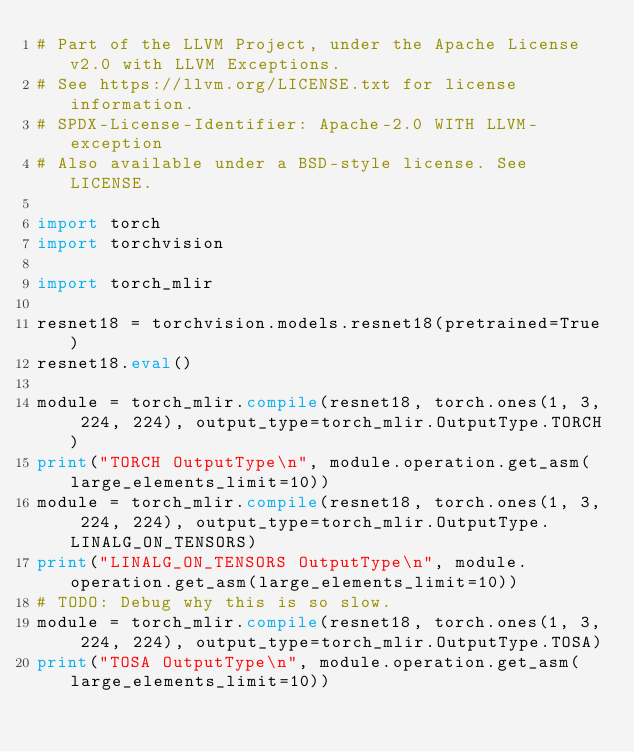Convert code to text. <code><loc_0><loc_0><loc_500><loc_500><_Python_># Part of the LLVM Project, under the Apache License v2.0 with LLVM Exceptions.
# See https://llvm.org/LICENSE.txt for license information.
# SPDX-License-Identifier: Apache-2.0 WITH LLVM-exception
# Also available under a BSD-style license. See LICENSE.

import torch
import torchvision

import torch_mlir

resnet18 = torchvision.models.resnet18(pretrained=True)
resnet18.eval()

module = torch_mlir.compile(resnet18, torch.ones(1, 3, 224, 224), output_type=torch_mlir.OutputType.TORCH)
print("TORCH OutputType\n", module.operation.get_asm(large_elements_limit=10))
module = torch_mlir.compile(resnet18, torch.ones(1, 3, 224, 224), output_type=torch_mlir.OutputType.LINALG_ON_TENSORS)
print("LINALG_ON_TENSORS OutputType\n", module.operation.get_asm(large_elements_limit=10))
# TODO: Debug why this is so slow.
module = torch_mlir.compile(resnet18, torch.ones(1, 3, 224, 224), output_type=torch_mlir.OutputType.TOSA)
print("TOSA OutputType\n", module.operation.get_asm(large_elements_limit=10))
</code> 